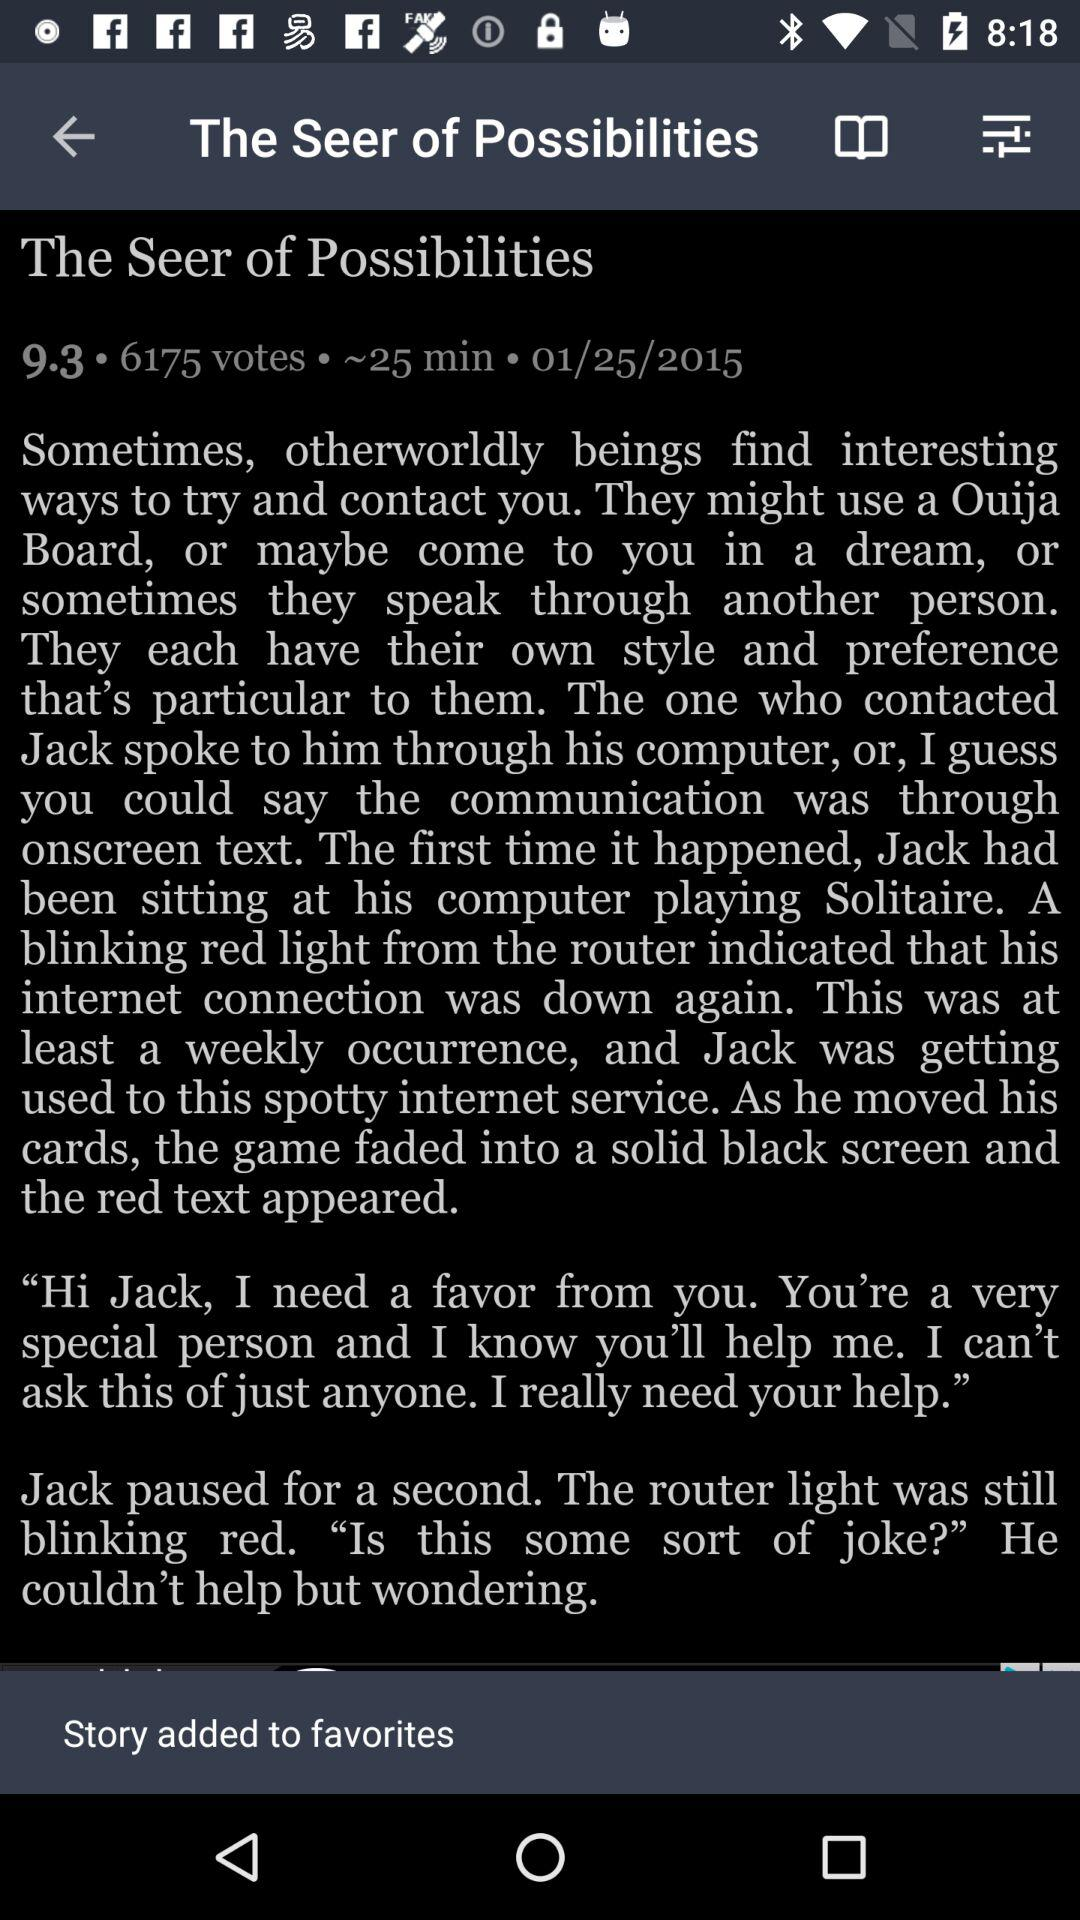How many votes does the story have?
Answer the question using a single word or phrase. 6175 